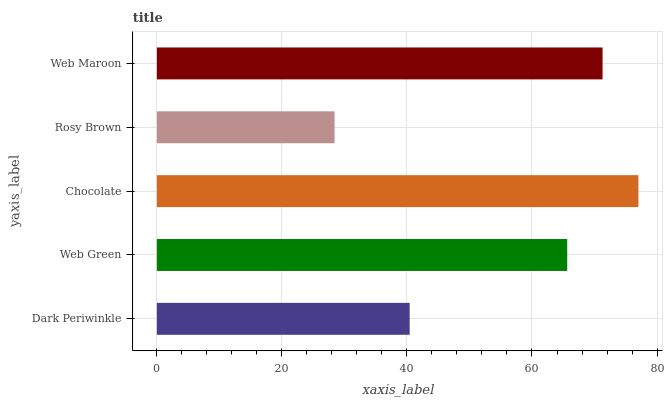Is Rosy Brown the minimum?
Answer yes or no. Yes. Is Chocolate the maximum?
Answer yes or no. Yes. Is Web Green the minimum?
Answer yes or no. No. Is Web Green the maximum?
Answer yes or no. No. Is Web Green greater than Dark Periwinkle?
Answer yes or no. Yes. Is Dark Periwinkle less than Web Green?
Answer yes or no. Yes. Is Dark Periwinkle greater than Web Green?
Answer yes or no. No. Is Web Green less than Dark Periwinkle?
Answer yes or no. No. Is Web Green the high median?
Answer yes or no. Yes. Is Web Green the low median?
Answer yes or no. Yes. Is Web Maroon the high median?
Answer yes or no. No. Is Rosy Brown the low median?
Answer yes or no. No. 